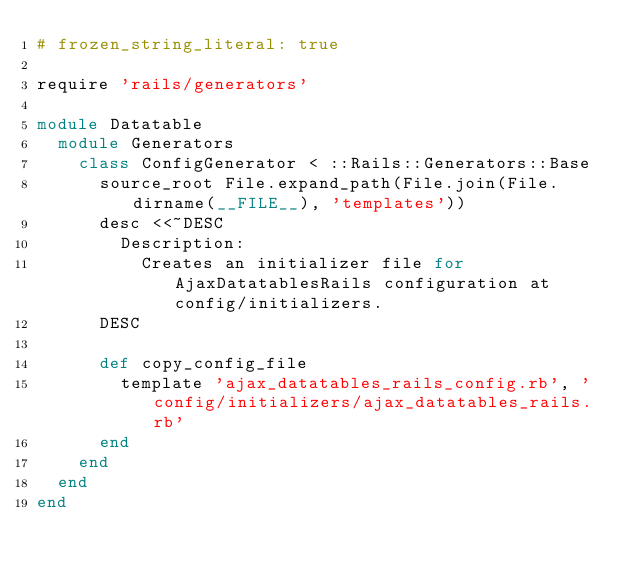<code> <loc_0><loc_0><loc_500><loc_500><_Ruby_># frozen_string_literal: true

require 'rails/generators'

module Datatable
  module Generators
    class ConfigGenerator < ::Rails::Generators::Base
      source_root File.expand_path(File.join(File.dirname(__FILE__), 'templates'))
      desc <<~DESC
        Description:
          Creates an initializer file for AjaxDatatablesRails configuration at config/initializers.
      DESC

      def copy_config_file
        template 'ajax_datatables_rails_config.rb', 'config/initializers/ajax_datatables_rails.rb'
      end
    end
  end
end
</code> 